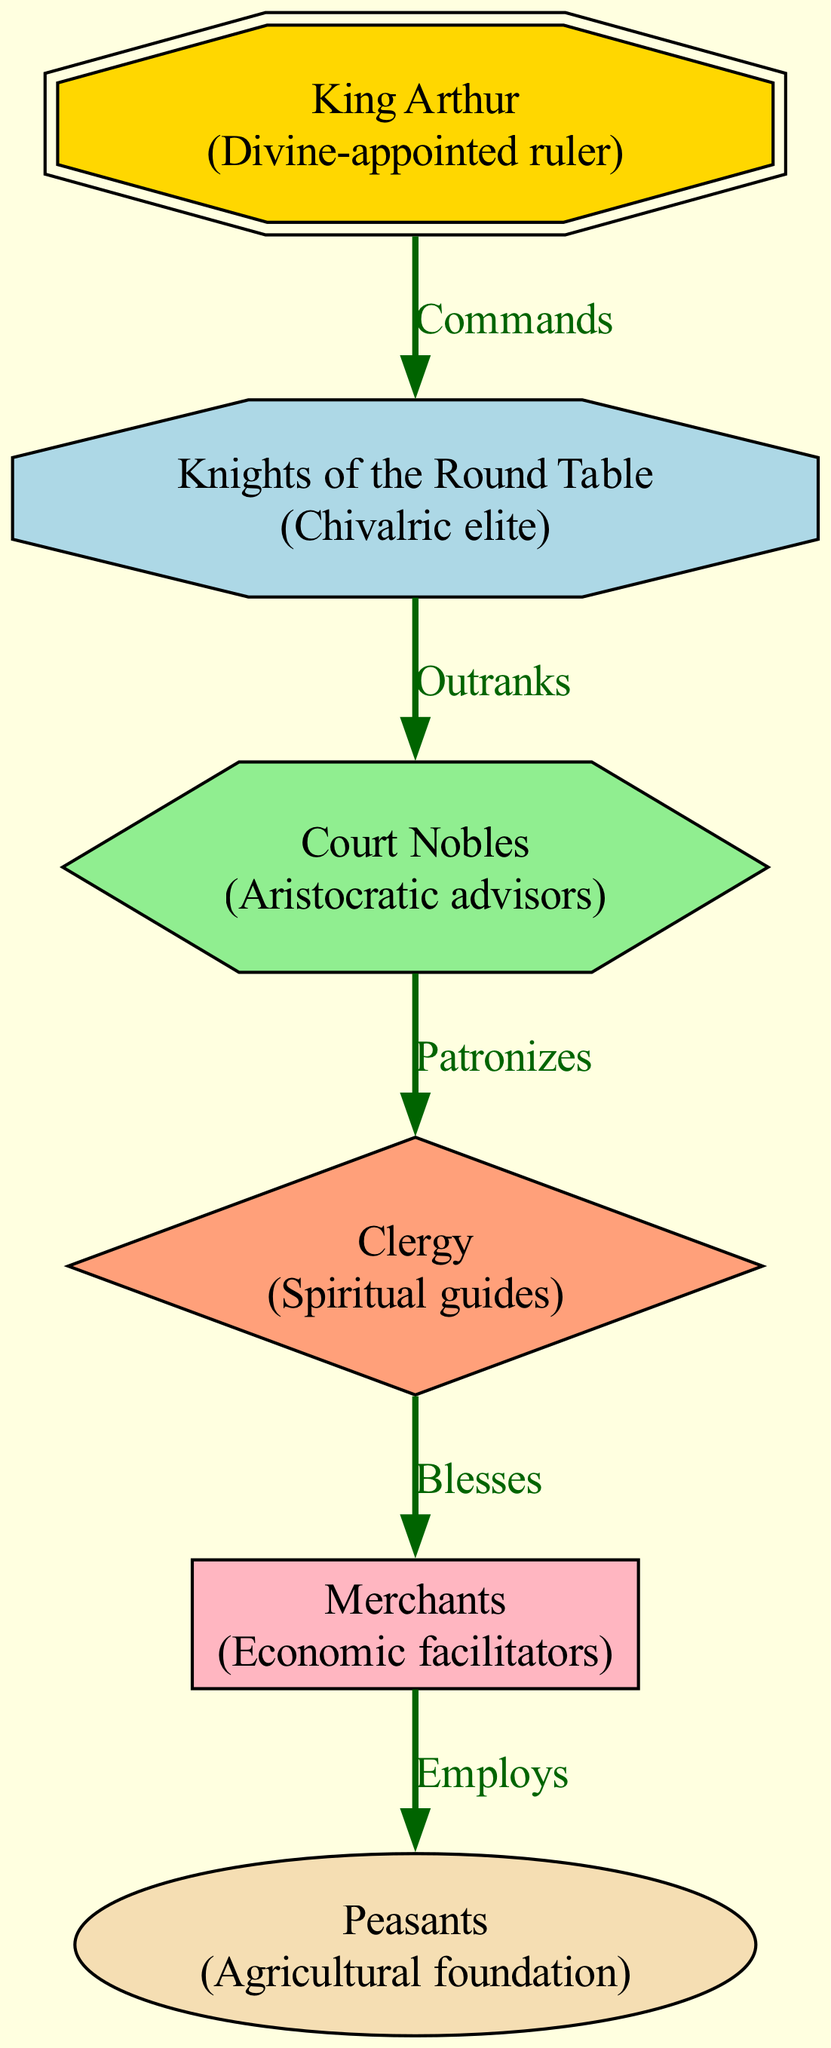What is the top node in the diagram? The top node represents the highest social class, which is King Arthur. Since the diagram depicts a food chain of social classes, the top position typically signifies authority or ultimate power.
Answer: King Arthur How many nodes are in the diagram? The diagram lists six distinct social classes, each represented by a node. To find this number, simply count the entries in the nodes section of the data.
Answer: 6 What relationship exists between the Knights of the Round Table and Court Nobles? The relationship defined between these two nodes is "Outranks," indicating that the Knights hold a higher position in the social hierarchy than the Court Nobles.
Answer: Outranks Which class is considered the economic facilitators? Among the nodes, the class labeled as merchants serves this role. This is evident through the description in the node data, where it states their function in the economy.
Answer: Merchants Which social class blesses the merchants? The edge directed from the clergy to the merchants indicates the role of blessing, suggesting that the clergy provides spiritual support or approval to the economic activities of the merchants.
Answer: Clergy Who employs the peasants? The link from the merchants to the peasants identifies the merchants as those who employ them, underscoring the economic dependence of the lower class on the economic facilitators.
Answer: Merchants What is the order of hierarchy from the highest to the lowest class? The top-down visualization implies a sequence: King Arthur commands the Knights, who outrank the Court Nobles, followed by the Clergy, which blesses the Merchants, who in turn employ the Peasants.
Answer: King Arthur, Knights of the Round Table, Court Nobles, Clergy, Merchants, Peasants What shape represents the Clergy? In examining the diagram, each node has a specific shape associated with it. The Clergy node is represented as a diamond.
Answer: Diamond Which class patronizes the clergy? The diagram does not indicate a reciprocal relationship from the clergy to any upper class but shows that the Court Nobles patronize the clergy, implying the Nobles support and uphold the Clergy's role in society.
Answer: Court Nobles 